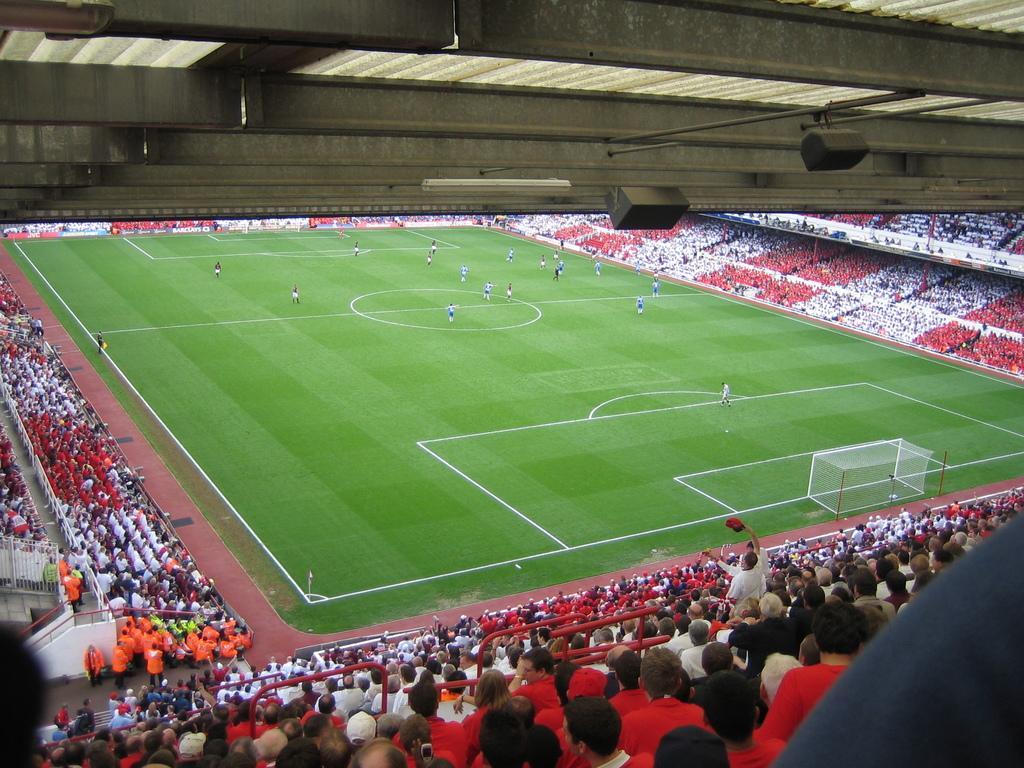Please provide a concise description of this image. In this image there are speakers, lights, roof, ground, people, railings, mesh and objects.   